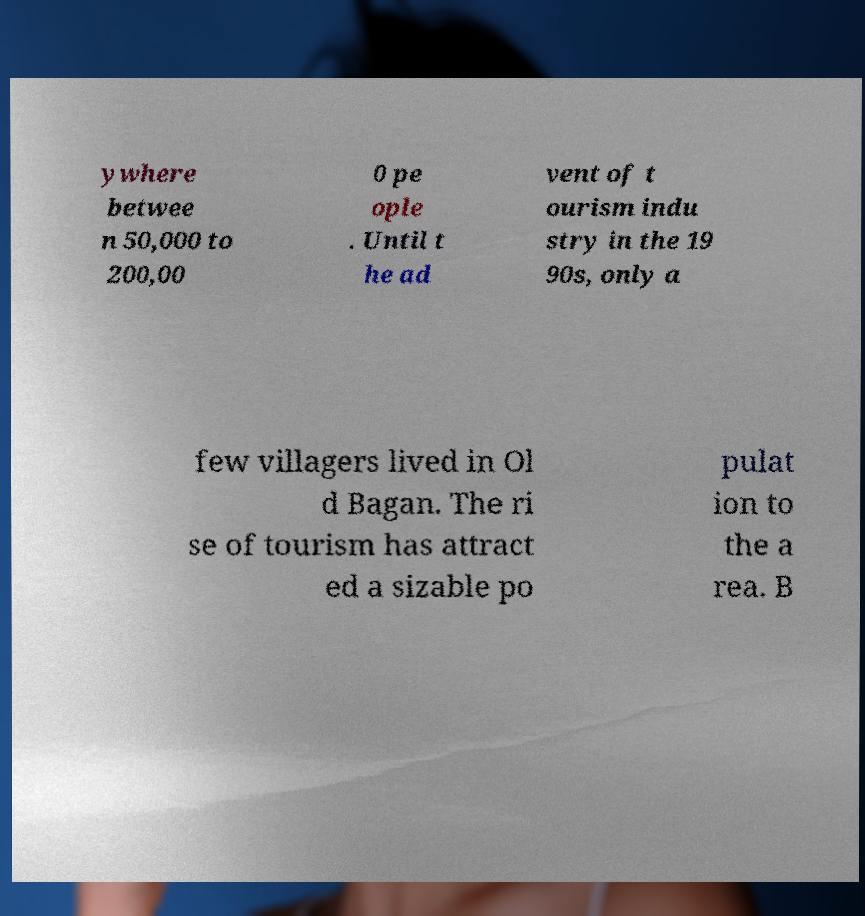Can you read and provide the text displayed in the image?This photo seems to have some interesting text. Can you extract and type it out for me? ywhere betwee n 50,000 to 200,00 0 pe ople . Until t he ad vent of t ourism indu stry in the 19 90s, only a few villagers lived in Ol d Bagan. The ri se of tourism has attract ed a sizable po pulat ion to the a rea. B 